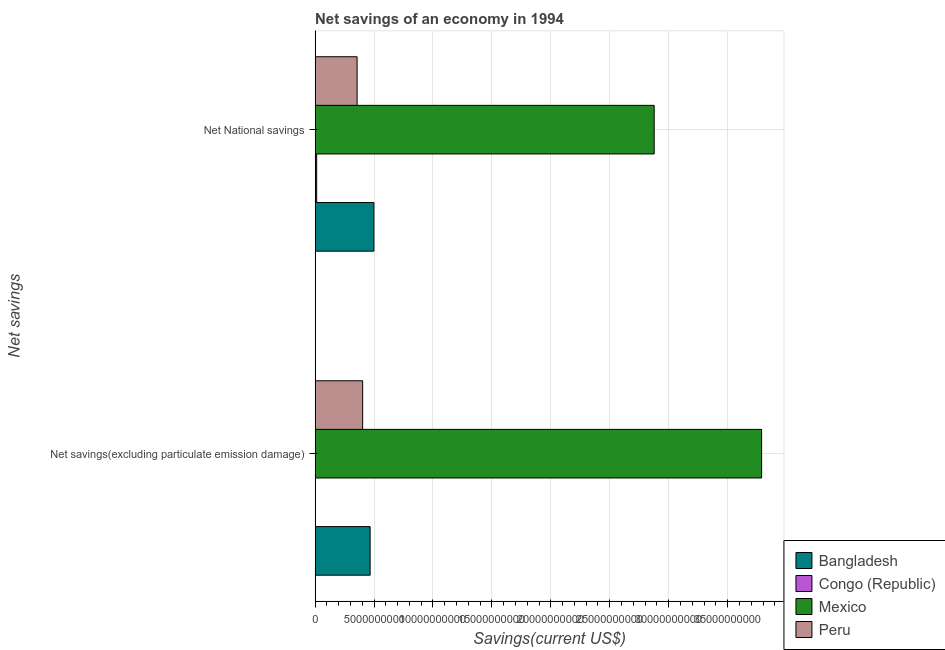How many different coloured bars are there?
Your response must be concise. 4. How many groups of bars are there?
Provide a succinct answer. 2. Are the number of bars per tick equal to the number of legend labels?
Provide a succinct answer. No. How many bars are there on the 2nd tick from the top?
Provide a succinct answer. 3. How many bars are there on the 1st tick from the bottom?
Provide a short and direct response. 3. What is the label of the 1st group of bars from the top?
Provide a succinct answer. Net National savings. What is the net savings(excluding particulate emission damage) in Bangladesh?
Give a very brief answer. 4.67e+09. Across all countries, what is the maximum net savings(excluding particulate emission damage)?
Give a very brief answer. 3.79e+1. Across all countries, what is the minimum net savings(excluding particulate emission damage)?
Make the answer very short. 0. In which country was the net savings(excluding particulate emission damage) maximum?
Your answer should be very brief. Mexico. What is the total net savings(excluding particulate emission damage) in the graph?
Offer a terse response. 4.66e+1. What is the difference between the net savings(excluding particulate emission damage) in Mexico and that in Bangladesh?
Keep it short and to the point. 3.32e+1. What is the difference between the net national savings in Congo (Republic) and the net savings(excluding particulate emission damage) in Peru?
Give a very brief answer. -3.90e+09. What is the average net savings(excluding particulate emission damage) per country?
Ensure brevity in your answer.  1.16e+1. What is the difference between the net national savings and net savings(excluding particulate emission damage) in Peru?
Give a very brief answer. -4.71e+08. In how many countries, is the net savings(excluding particulate emission damage) greater than 6000000000 US$?
Your response must be concise. 1. What is the ratio of the net national savings in Bangladesh to that in Mexico?
Provide a short and direct response. 0.17. In how many countries, is the net national savings greater than the average net national savings taken over all countries?
Offer a very short reply. 1. Are all the bars in the graph horizontal?
Provide a short and direct response. Yes. How many countries are there in the graph?
Keep it short and to the point. 4. What is the difference between two consecutive major ticks on the X-axis?
Your answer should be very brief. 5.00e+09. How are the legend labels stacked?
Make the answer very short. Vertical. What is the title of the graph?
Provide a short and direct response. Net savings of an economy in 1994. What is the label or title of the X-axis?
Keep it short and to the point. Savings(current US$). What is the label or title of the Y-axis?
Ensure brevity in your answer.  Net savings. What is the Savings(current US$) in Bangladesh in Net savings(excluding particulate emission damage)?
Provide a short and direct response. 4.67e+09. What is the Savings(current US$) in Congo (Republic) in Net savings(excluding particulate emission damage)?
Keep it short and to the point. 0. What is the Savings(current US$) in Mexico in Net savings(excluding particulate emission damage)?
Offer a very short reply. 3.79e+1. What is the Savings(current US$) in Peru in Net savings(excluding particulate emission damage)?
Offer a terse response. 4.03e+09. What is the Savings(current US$) of Bangladesh in Net National savings?
Provide a short and direct response. 4.99e+09. What is the Savings(current US$) in Congo (Republic) in Net National savings?
Your answer should be compact. 1.34e+08. What is the Savings(current US$) in Mexico in Net National savings?
Your answer should be very brief. 2.88e+1. What is the Savings(current US$) of Peru in Net National savings?
Give a very brief answer. 3.56e+09. Across all Net savings, what is the maximum Savings(current US$) of Bangladesh?
Provide a succinct answer. 4.99e+09. Across all Net savings, what is the maximum Savings(current US$) in Congo (Republic)?
Make the answer very short. 1.34e+08. Across all Net savings, what is the maximum Savings(current US$) of Mexico?
Offer a terse response. 3.79e+1. Across all Net savings, what is the maximum Savings(current US$) of Peru?
Make the answer very short. 4.03e+09. Across all Net savings, what is the minimum Savings(current US$) in Bangladesh?
Your answer should be very brief. 4.67e+09. Across all Net savings, what is the minimum Savings(current US$) in Mexico?
Offer a terse response. 2.88e+1. Across all Net savings, what is the minimum Savings(current US$) in Peru?
Provide a succinct answer. 3.56e+09. What is the total Savings(current US$) in Bangladesh in the graph?
Your answer should be very brief. 9.66e+09. What is the total Savings(current US$) in Congo (Republic) in the graph?
Ensure brevity in your answer.  1.34e+08. What is the total Savings(current US$) of Mexico in the graph?
Offer a very short reply. 6.66e+1. What is the total Savings(current US$) of Peru in the graph?
Keep it short and to the point. 7.60e+09. What is the difference between the Savings(current US$) in Bangladesh in Net savings(excluding particulate emission damage) and that in Net National savings?
Provide a succinct answer. -3.22e+08. What is the difference between the Savings(current US$) in Mexico in Net savings(excluding particulate emission damage) and that in Net National savings?
Your response must be concise. 9.11e+09. What is the difference between the Savings(current US$) in Peru in Net savings(excluding particulate emission damage) and that in Net National savings?
Offer a very short reply. 4.71e+08. What is the difference between the Savings(current US$) of Bangladesh in Net savings(excluding particulate emission damage) and the Savings(current US$) of Congo (Republic) in Net National savings?
Keep it short and to the point. 4.53e+09. What is the difference between the Savings(current US$) in Bangladesh in Net savings(excluding particulate emission damage) and the Savings(current US$) in Mexico in Net National savings?
Your response must be concise. -2.41e+1. What is the difference between the Savings(current US$) in Bangladesh in Net savings(excluding particulate emission damage) and the Savings(current US$) in Peru in Net National savings?
Provide a succinct answer. 1.11e+09. What is the difference between the Savings(current US$) of Mexico in Net savings(excluding particulate emission damage) and the Savings(current US$) of Peru in Net National savings?
Your response must be concise. 3.43e+1. What is the average Savings(current US$) of Bangladesh per Net savings?
Your answer should be very brief. 4.83e+09. What is the average Savings(current US$) in Congo (Republic) per Net savings?
Provide a short and direct response. 6.68e+07. What is the average Savings(current US$) in Mexico per Net savings?
Your answer should be compact. 3.33e+1. What is the average Savings(current US$) of Peru per Net savings?
Your response must be concise. 3.80e+09. What is the difference between the Savings(current US$) of Bangladesh and Savings(current US$) of Mexico in Net savings(excluding particulate emission damage)?
Provide a succinct answer. -3.32e+1. What is the difference between the Savings(current US$) of Bangladesh and Savings(current US$) of Peru in Net savings(excluding particulate emission damage)?
Provide a short and direct response. 6.34e+08. What is the difference between the Savings(current US$) of Mexico and Savings(current US$) of Peru in Net savings(excluding particulate emission damage)?
Keep it short and to the point. 3.38e+1. What is the difference between the Savings(current US$) of Bangladesh and Savings(current US$) of Congo (Republic) in Net National savings?
Keep it short and to the point. 4.86e+09. What is the difference between the Savings(current US$) of Bangladesh and Savings(current US$) of Mexico in Net National savings?
Provide a short and direct response. -2.38e+1. What is the difference between the Savings(current US$) in Bangladesh and Savings(current US$) in Peru in Net National savings?
Offer a terse response. 1.43e+09. What is the difference between the Savings(current US$) in Congo (Republic) and Savings(current US$) in Mexico in Net National savings?
Your response must be concise. -2.86e+1. What is the difference between the Savings(current US$) of Congo (Republic) and Savings(current US$) of Peru in Net National savings?
Your answer should be compact. -3.43e+09. What is the difference between the Savings(current US$) in Mexico and Savings(current US$) in Peru in Net National savings?
Keep it short and to the point. 2.52e+1. What is the ratio of the Savings(current US$) of Bangladesh in Net savings(excluding particulate emission damage) to that in Net National savings?
Give a very brief answer. 0.94. What is the ratio of the Savings(current US$) of Mexico in Net savings(excluding particulate emission damage) to that in Net National savings?
Make the answer very short. 1.32. What is the ratio of the Savings(current US$) of Peru in Net savings(excluding particulate emission damage) to that in Net National savings?
Your answer should be very brief. 1.13. What is the difference between the highest and the second highest Savings(current US$) in Bangladesh?
Offer a very short reply. 3.22e+08. What is the difference between the highest and the second highest Savings(current US$) of Mexico?
Your answer should be very brief. 9.11e+09. What is the difference between the highest and the second highest Savings(current US$) in Peru?
Offer a very short reply. 4.71e+08. What is the difference between the highest and the lowest Savings(current US$) in Bangladesh?
Ensure brevity in your answer.  3.22e+08. What is the difference between the highest and the lowest Savings(current US$) of Congo (Republic)?
Your answer should be compact. 1.34e+08. What is the difference between the highest and the lowest Savings(current US$) of Mexico?
Make the answer very short. 9.11e+09. What is the difference between the highest and the lowest Savings(current US$) of Peru?
Make the answer very short. 4.71e+08. 